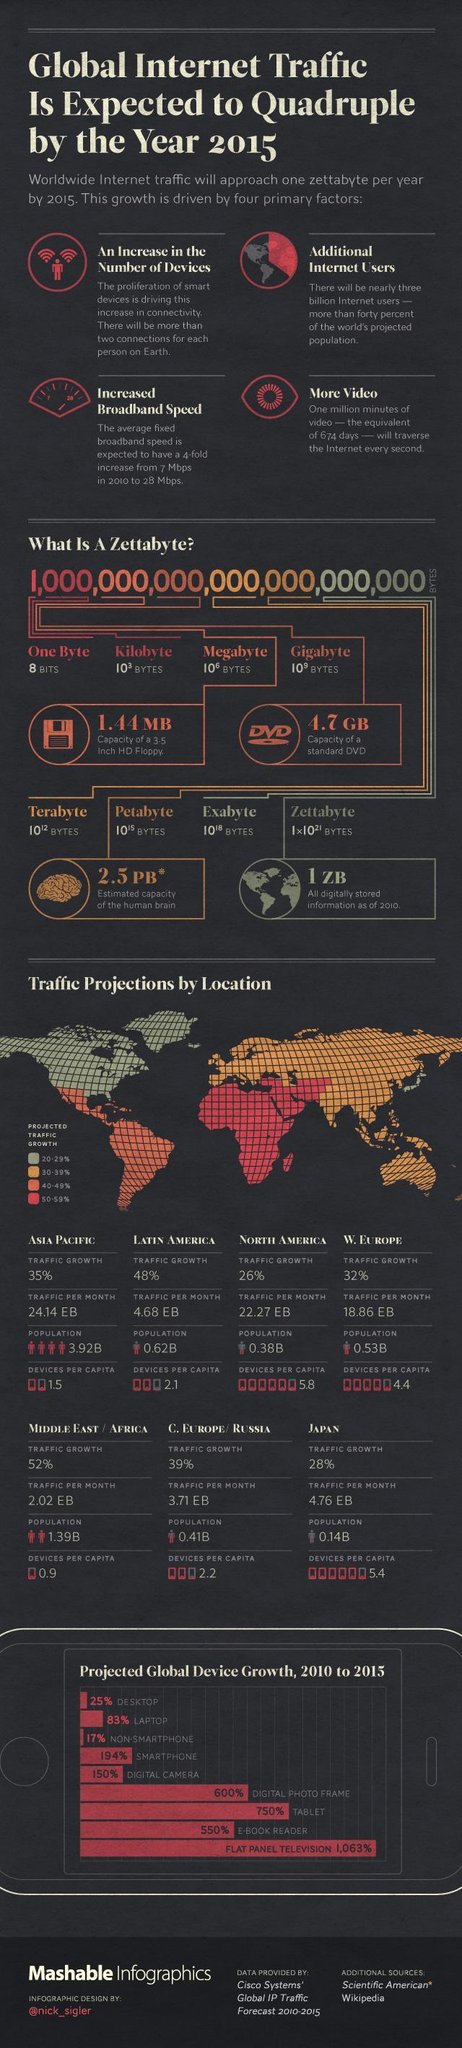By what percent will projected global growth of smart phone increase in 5 years?
Answer the question with a short phrase. 194% What is the difference between the projected global growth of tablet and e-book reader? 200% Which region has a projected traffic growth of 50-59%? MIDDLE EAST/AFRICA Which device is predicted to have the highest growth in five years? FLAT PANEL TELEVISION Which regions have traffic per month above 20 EB? ASIA PACIFIC, NORTH AMERICA Which region has the highest traffic growth? MIDDLE EAST/AFRICA 